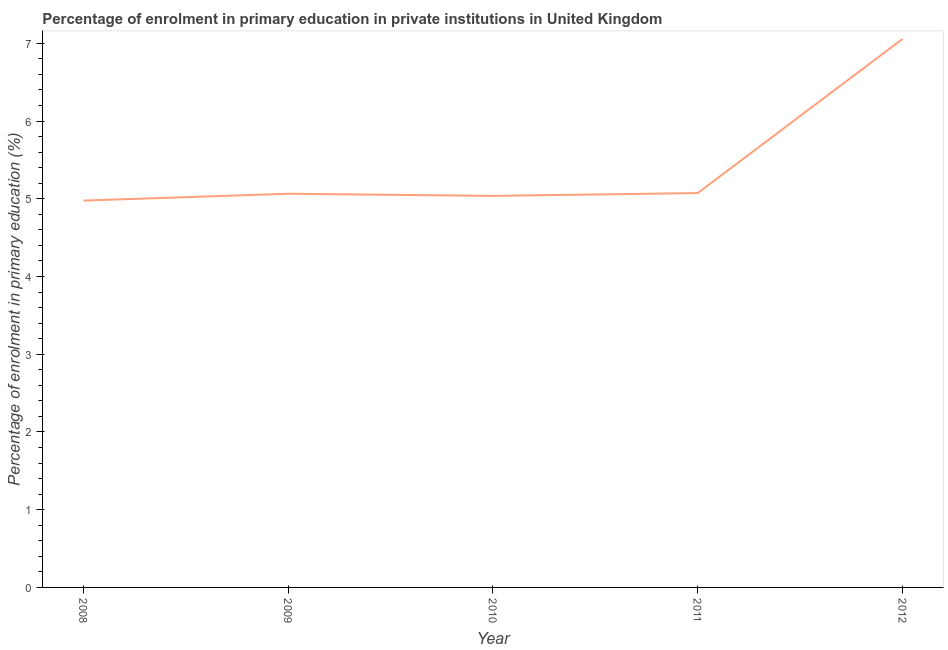What is the enrolment percentage in primary education in 2012?
Provide a short and direct response. 7.06. Across all years, what is the maximum enrolment percentage in primary education?
Provide a succinct answer. 7.06. Across all years, what is the minimum enrolment percentage in primary education?
Make the answer very short. 4.98. In which year was the enrolment percentage in primary education maximum?
Your answer should be very brief. 2012. What is the sum of the enrolment percentage in primary education?
Provide a succinct answer. 27.21. What is the difference between the enrolment percentage in primary education in 2009 and 2012?
Your answer should be very brief. -1.99. What is the average enrolment percentage in primary education per year?
Your response must be concise. 5.44. What is the median enrolment percentage in primary education?
Offer a very short reply. 5.06. Do a majority of the years between 2012 and 2008 (inclusive) have enrolment percentage in primary education greater than 2.8 %?
Your answer should be very brief. Yes. What is the ratio of the enrolment percentage in primary education in 2008 to that in 2009?
Offer a terse response. 0.98. Is the difference between the enrolment percentage in primary education in 2010 and 2012 greater than the difference between any two years?
Offer a terse response. No. What is the difference between the highest and the second highest enrolment percentage in primary education?
Make the answer very short. 1.98. What is the difference between the highest and the lowest enrolment percentage in primary education?
Offer a terse response. 2.08. Does the enrolment percentage in primary education monotonically increase over the years?
Offer a terse response. No. What is the difference between two consecutive major ticks on the Y-axis?
Provide a short and direct response. 1. What is the title of the graph?
Offer a terse response. Percentage of enrolment in primary education in private institutions in United Kingdom. What is the label or title of the Y-axis?
Your answer should be very brief. Percentage of enrolment in primary education (%). What is the Percentage of enrolment in primary education (%) in 2008?
Your answer should be very brief. 4.98. What is the Percentage of enrolment in primary education (%) of 2009?
Ensure brevity in your answer.  5.06. What is the Percentage of enrolment in primary education (%) in 2010?
Offer a very short reply. 5.04. What is the Percentage of enrolment in primary education (%) in 2011?
Keep it short and to the point. 5.07. What is the Percentage of enrolment in primary education (%) of 2012?
Give a very brief answer. 7.06. What is the difference between the Percentage of enrolment in primary education (%) in 2008 and 2009?
Provide a short and direct response. -0.09. What is the difference between the Percentage of enrolment in primary education (%) in 2008 and 2010?
Your response must be concise. -0.06. What is the difference between the Percentage of enrolment in primary education (%) in 2008 and 2011?
Offer a terse response. -0.1. What is the difference between the Percentage of enrolment in primary education (%) in 2008 and 2012?
Offer a terse response. -2.08. What is the difference between the Percentage of enrolment in primary education (%) in 2009 and 2010?
Offer a terse response. 0.03. What is the difference between the Percentage of enrolment in primary education (%) in 2009 and 2011?
Your response must be concise. -0.01. What is the difference between the Percentage of enrolment in primary education (%) in 2009 and 2012?
Your answer should be compact. -1.99. What is the difference between the Percentage of enrolment in primary education (%) in 2010 and 2011?
Your response must be concise. -0.04. What is the difference between the Percentage of enrolment in primary education (%) in 2010 and 2012?
Provide a short and direct response. -2.02. What is the difference between the Percentage of enrolment in primary education (%) in 2011 and 2012?
Your response must be concise. -1.98. What is the ratio of the Percentage of enrolment in primary education (%) in 2008 to that in 2010?
Give a very brief answer. 0.99. What is the ratio of the Percentage of enrolment in primary education (%) in 2008 to that in 2011?
Your answer should be compact. 0.98. What is the ratio of the Percentage of enrolment in primary education (%) in 2008 to that in 2012?
Make the answer very short. 0.7. What is the ratio of the Percentage of enrolment in primary education (%) in 2009 to that in 2011?
Ensure brevity in your answer.  1. What is the ratio of the Percentage of enrolment in primary education (%) in 2009 to that in 2012?
Your response must be concise. 0.72. What is the ratio of the Percentage of enrolment in primary education (%) in 2010 to that in 2012?
Offer a very short reply. 0.71. What is the ratio of the Percentage of enrolment in primary education (%) in 2011 to that in 2012?
Make the answer very short. 0.72. 